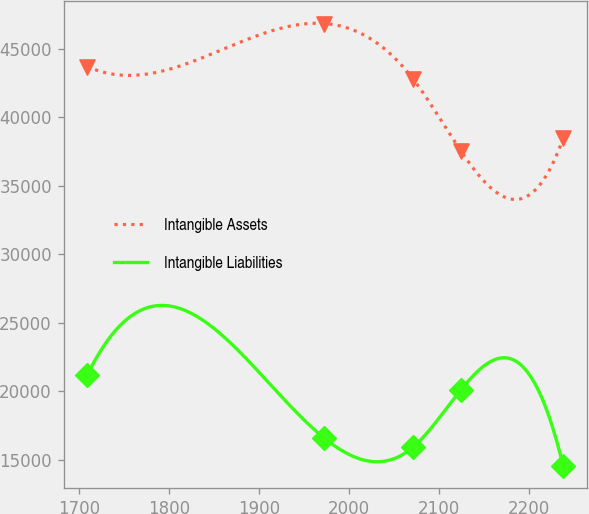<chart> <loc_0><loc_0><loc_500><loc_500><line_chart><ecel><fcel>Intangible Assets<fcel>Intangible Liabilities<nl><fcel>1708.73<fcel>43717.2<fcel>21197.9<nl><fcel>1971.98<fcel>46857.4<fcel>16606.2<nl><fcel>2071.45<fcel>42786.3<fcel>15941.2<nl><fcel>2124.4<fcel>37548.2<fcel>20109.1<nl><fcel>2238.28<fcel>38479.1<fcel>14548.1<nl></chart> 